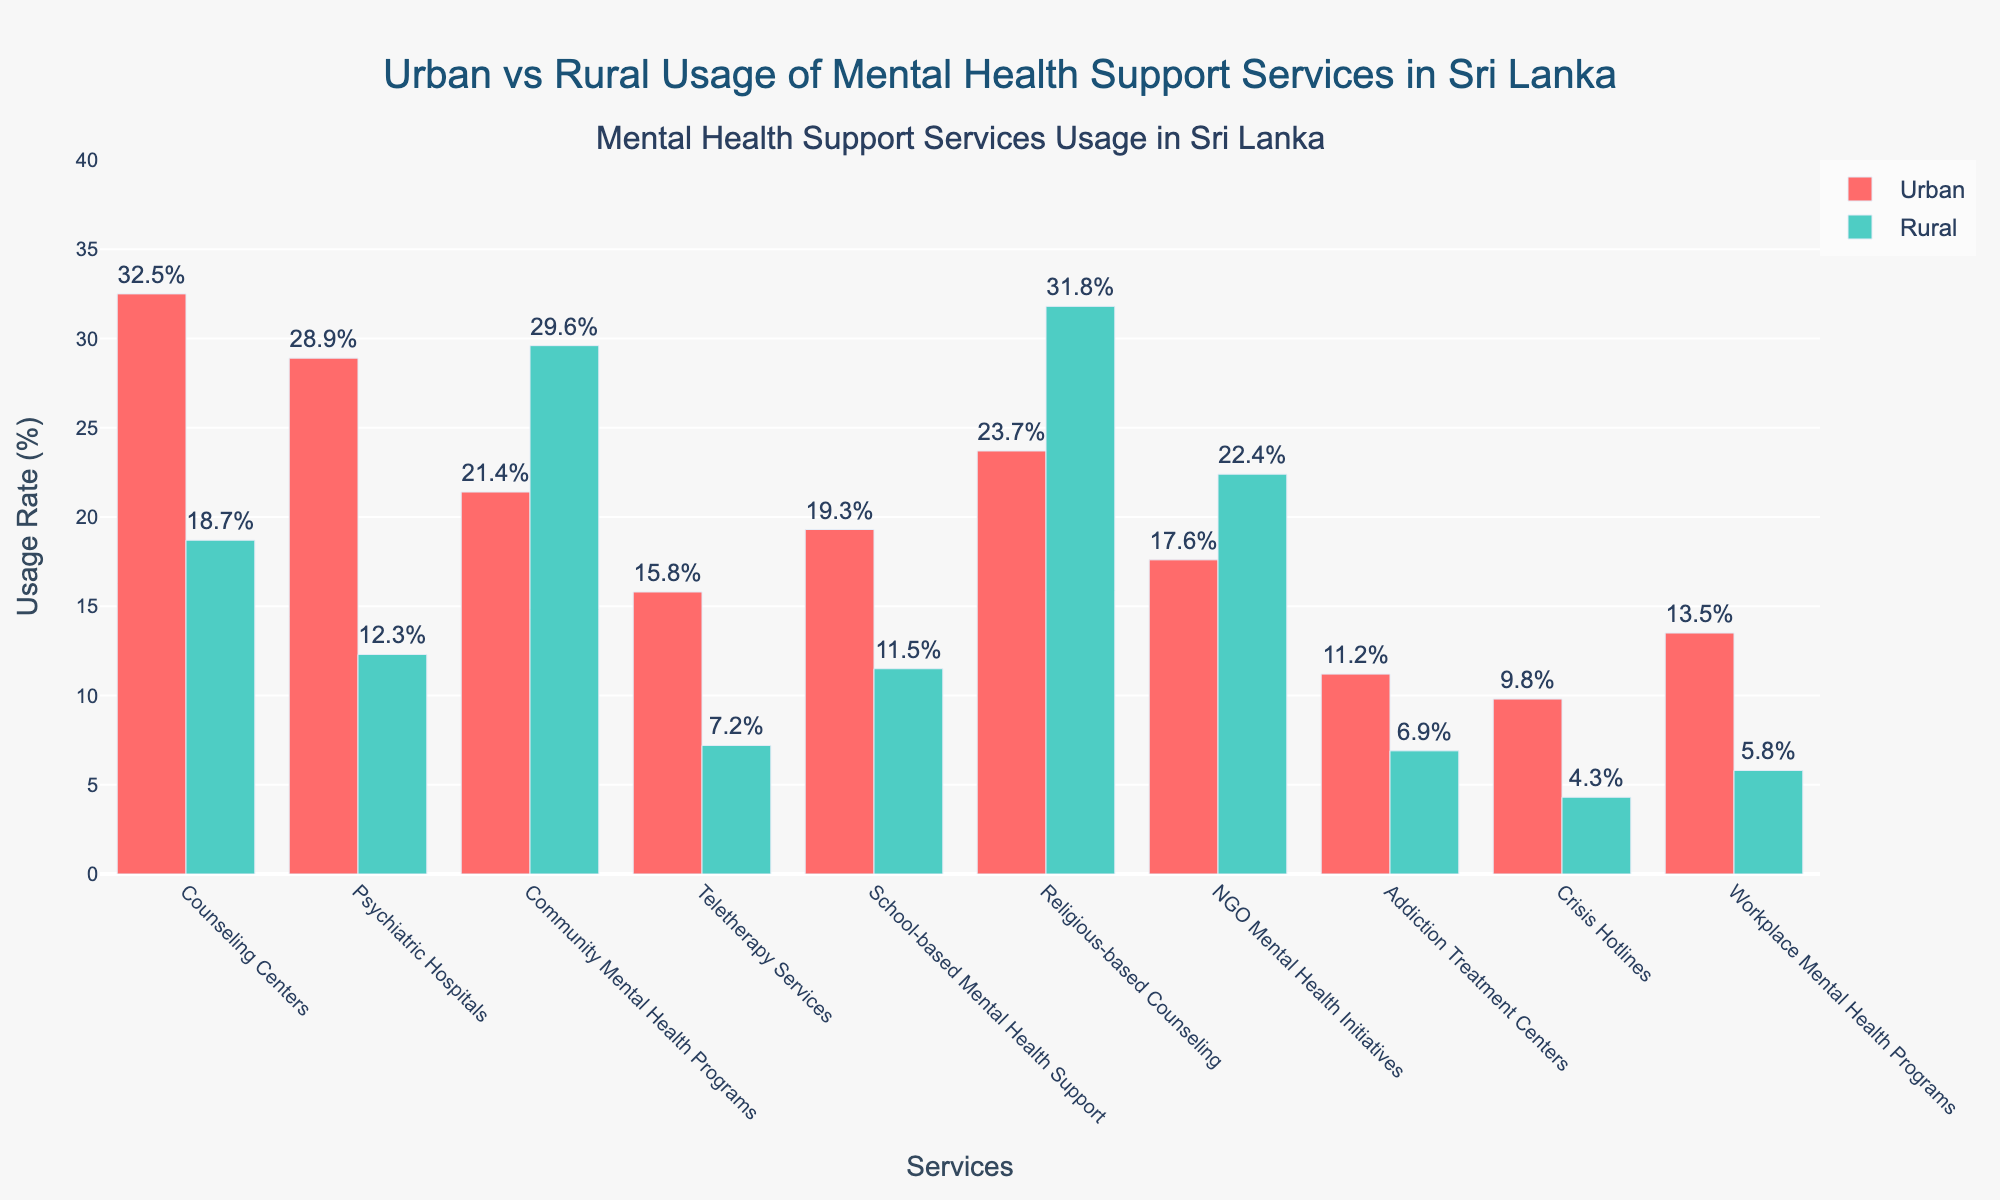Which mental health support service has the highest usage rate in urban areas? By looking at the red bars representing urban usage, the Counseling Centers have the tallest bar.
Answer: Counseling Centers Which service shows a higher usage rate in rural areas compared to urban areas? In the figure, the green bars represent rural usage and Religious-based Counseling has a taller green bar (31.8%) than red bar (23.7%).
Answer: Religious-based Counseling What's the difference in usage rates between urban and rural areas for Psychiatric Hospitals? Subtract the rural rate from the urban rate: 28.9% (urban) - 12.3% (rural) = 16.6%.
Answer: 16.6% Which service has the least usage rate in rural areas? The smallest green bar corresponds to Crisis Hotlines with 4.3%.
Answer: Crisis Hotlines For which service is the usage rate in urban areas more than double the usage rate in rural areas? By comparing the values, Counseling Centers (32.5% vs 18.7%), Psychiatric Hospitals (28.9% vs 12.3%), and Teletherapy Services (15.8% vs 7.2%) all fit this condition.
Answer: Counseling Centers, Psychiatric Hospitals, Teletherapy Services What's the total usage rate for Urban areas for Counseling Centers, Teletherapy Services, and Crisis Hotlines combined? Sum the urban rates: 32.5% + 15.8% + 9.8% = 58.1%.
Answer: 58.1% Which service has the smallest difference in usage rates between urban and rural areas? Calculate the differences and compare: NGO Mental Health Initiatives has the smallest difference with 17.6% (urban) - 22.4% (rural) = -4.8%.
Answer: NGO Mental Health Initiatives Which services have higher usage rates in rural areas than the overall usage rate of Crisis Hotlines in urban areas? Compare Crisis Hotlines urban rate (9.8%) to rural rates: Community Mental Health Programs (29.6%), Religious-based Counseling (31.8%), and NGO Mental Health Initiatives (22.4%).
Answer: Community Mental Health Programs, Religious-based Counseling, NGO Mental Health Initiatives What's the average usage rate in rural areas for the services that have higher usage in rural than urban areas? Average the rural rates of Community Mental Health Programs (29.6%) and Religious-based Counseling (31.8%): (29.6 + 31.8)/2 = 30.7%.
Answer: 30.7% What's the combined percentage of school-based support, addiction treatment centers, and workplace mental health programs in rural areas? Sum: School-based Mental Health Support (11.5%) + Addiction Treatment Centers (6.9%) + Workplace Mental Health Programs (5.8%) = 24.2%.
Answer: 24.2% 